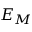Convert formula to latex. <formula><loc_0><loc_0><loc_500><loc_500>E _ { M }</formula> 